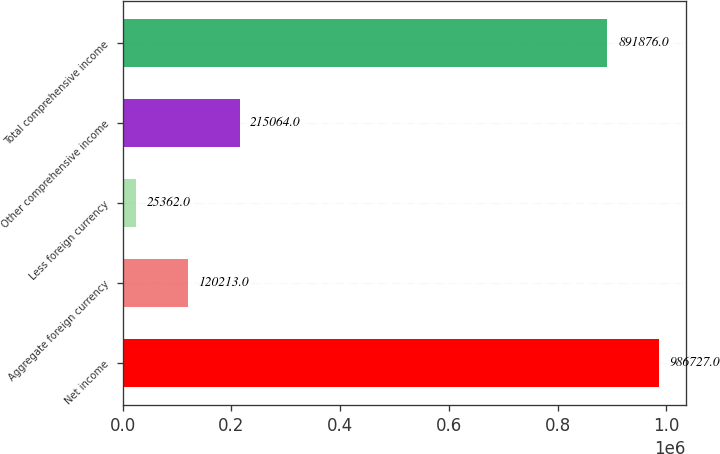Convert chart. <chart><loc_0><loc_0><loc_500><loc_500><bar_chart><fcel>Net income<fcel>Aggregate foreign currency<fcel>Less foreign currency<fcel>Other comprehensive income<fcel>Total comprehensive income<nl><fcel>986727<fcel>120213<fcel>25362<fcel>215064<fcel>891876<nl></chart> 